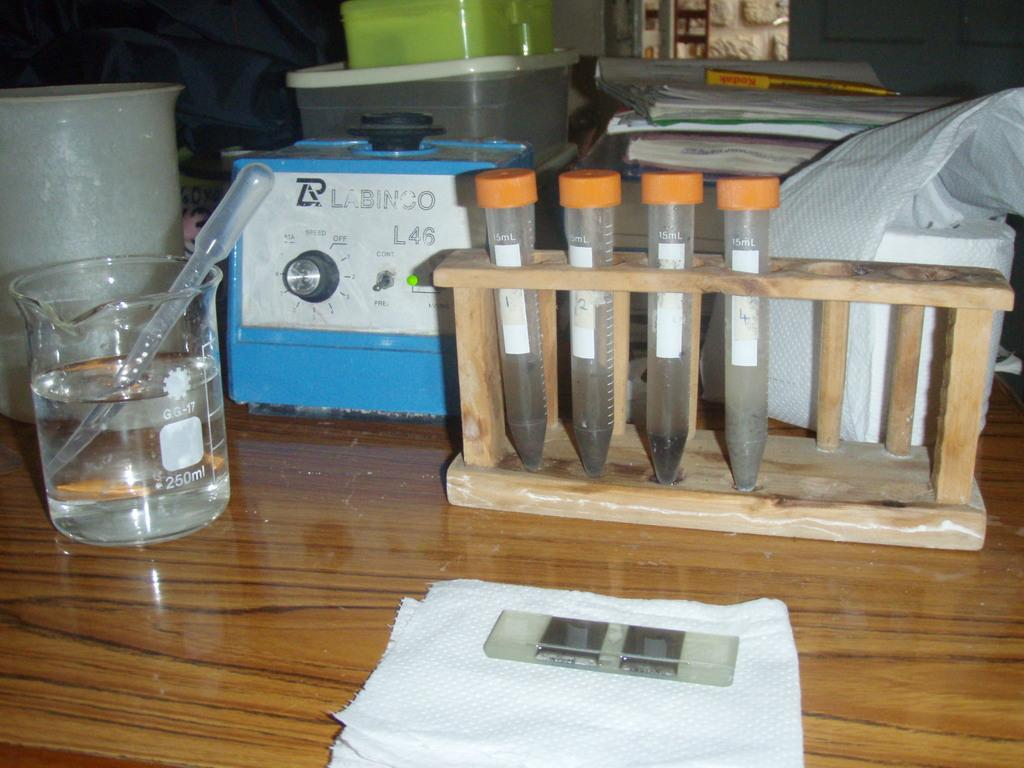<image>
Share a concise interpretation of the image provided. A table with test tubes and slides and a beaker and a centrifuge that says LABINCO. 